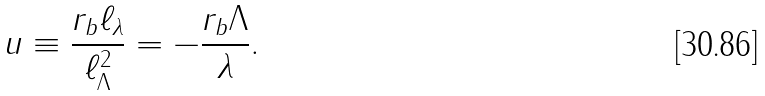<formula> <loc_0><loc_0><loc_500><loc_500>u \equiv \frac { r _ { b } \ell _ { \lambda } } { \ell _ { \Lambda } ^ { 2 } } = - \frac { r _ { b } \Lambda } { \lambda } .</formula> 